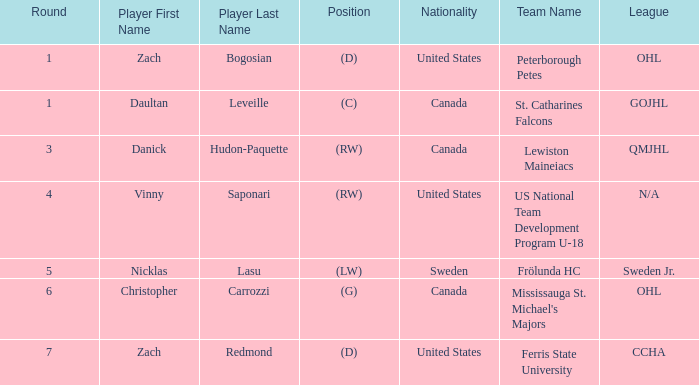What is the Player in Round 5? Nicklas Lasu. 